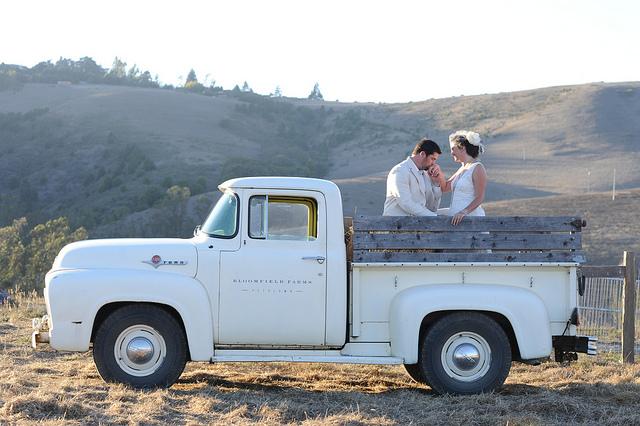Are these people wearing wedding attire?
Give a very brief answer. Yes. What are the people celebrating?
Keep it brief. Wedding. What type of car is this?
Quick response, please. Truck. 